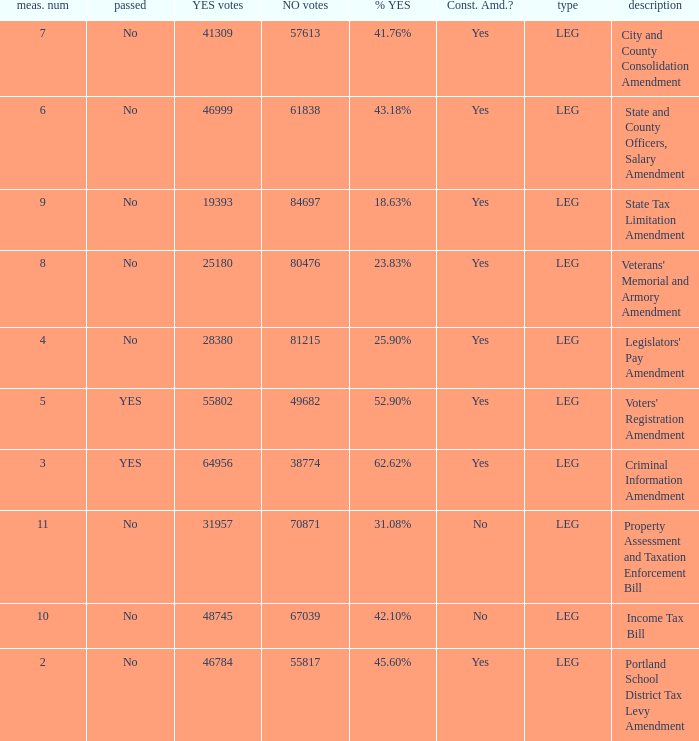HOw many no votes were there when there were 45.60% yes votes 55817.0. 